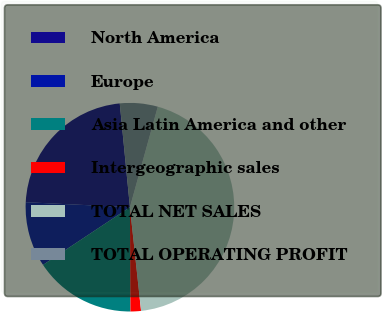<chart> <loc_0><loc_0><loc_500><loc_500><pie_chart><fcel>North America<fcel>Europe<fcel>Asia Latin America and other<fcel>Intergeographic sales<fcel>TOTAL NET SALES<fcel>TOTAL OPERATING PROFIT<nl><fcel>22.68%<fcel>10.09%<fcel>15.76%<fcel>1.62%<fcel>43.99%<fcel>5.86%<nl></chart> 